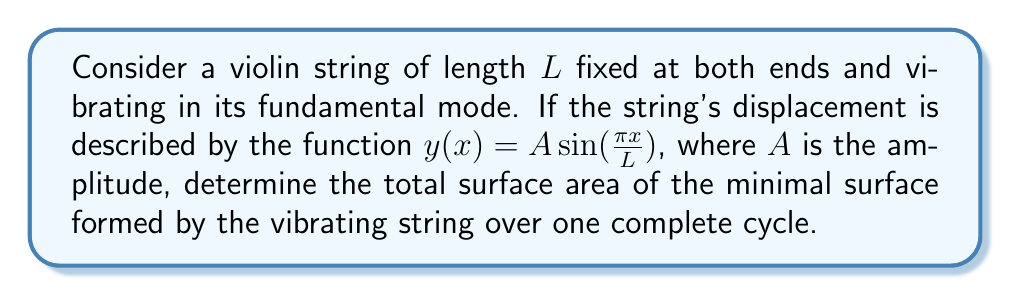Show me your answer to this math problem. Let's approach this step-by-step:

1) The minimal surface formed by a vibrating string is a catenoid. To find its surface area, we need to set up and evaluate a surface integral.

2) The surface area of a parametric surface is given by:

   $$S = \int_{0}^{L} \int_{0}^{2\pi} \sqrt{1 + (\frac{\partial y}{\partial x})^2 + (\frac{\partial y}{\partial t})^2} dx dt$$

   where $t$ represents time over one cycle $(0 \leq t \leq 2\pi)$.

3) We need to find $\frac{\partial y}{\partial x}$ and $\frac{\partial y}{\partial t}$:

   $$\frac{\partial y}{\partial x} = \frac{A\pi}{L} \cos(\frac{\pi x}{L})$$
   $$\frac{\partial y}{\partial t} = A\omega \sin(\frac{\pi x}{L}) \cos(\omega t)$$

   where $\omega$ is the angular frequency.

4) Substituting these into our surface area integral:

   $$S = \int_{0}^{L} \int_{0}^{2\pi} \sqrt{1 + (\frac{A\pi}{L})^2 \cos^2(\frac{\pi x}{L}) + A^2\omega^2 \sin^2(\frac{\pi x}{L}) \cos^2(\omega t)} dx dt$$

5) This integral is complex and doesn't have a simple closed-form solution. However, we can approximate it using the assumption that the amplitude $A$ is small compared to the length $L$. This allows us to use a Taylor expansion:

   $$\sqrt{1+x} \approx 1 + \frac{x}{2} - \frac{x^2}{8} + ...$$

6) Applying this approximation and keeping only the first-order terms:

   $$S \approx \int_{0}^{L} \int_{0}^{2\pi} (1 + \frac{1}{2}[(\frac{A\pi}{L})^2 \cos^2(\frac{\pi x}{L}) + A^2\omega^2 \sin^2(\frac{\pi x}{L}) \cos^2(\omega t)]) dx dt$$

7) Evaluating this integral:

   $$S \approx 2\pi L + \pi^3 A^2 + \pi L A^2 \omega^2$$

8) For a vibrating string, $\omega = \frac{\pi}{L}\sqrt{\frac{T}{\mu}}$, where $T$ is the tension and $\mu$ is the linear mass density. Substituting this:

   $$S \approx 2\pi L + \pi^3 A^2 + \pi^3 A^2 \frac{T}{\mu L^2}$$

This is our final approximation for the surface area.
Answer: $S \approx 2\pi L + \pi^3 A^2 (1 + \frac{T}{\mu L^2})$ 